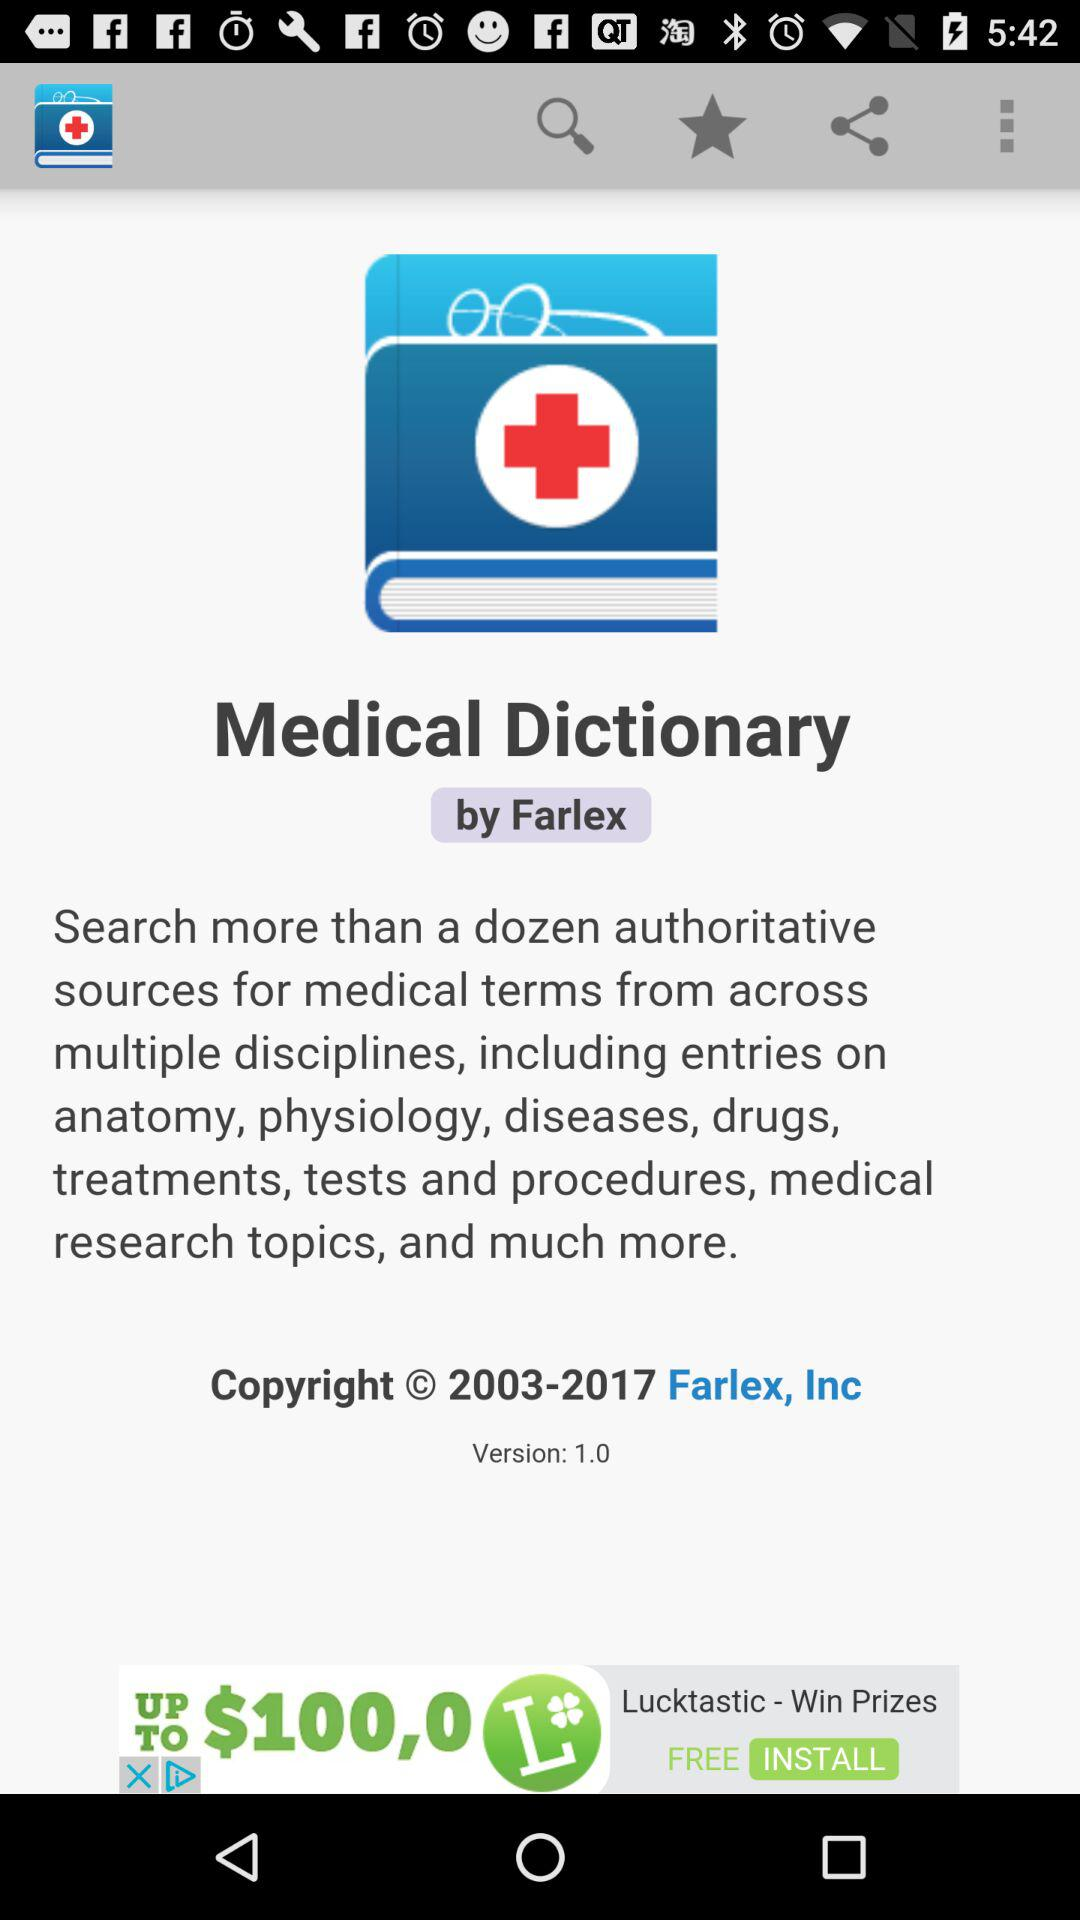What is the version of "Medical Dictionary"? The version is 1.0. 